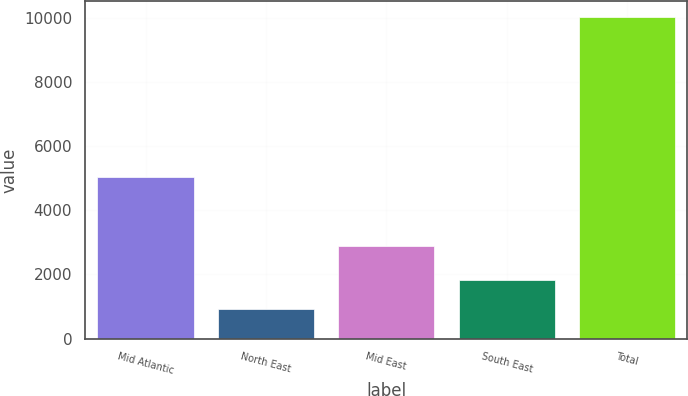Convert chart to OTSL. <chart><loc_0><loc_0><loc_500><loc_500><bar_chart><fcel>Mid Atlantic<fcel>North East<fcel>Mid East<fcel>South East<fcel>Total<nl><fcel>5043<fcel>920<fcel>2886<fcel>1831<fcel>10030<nl></chart> 